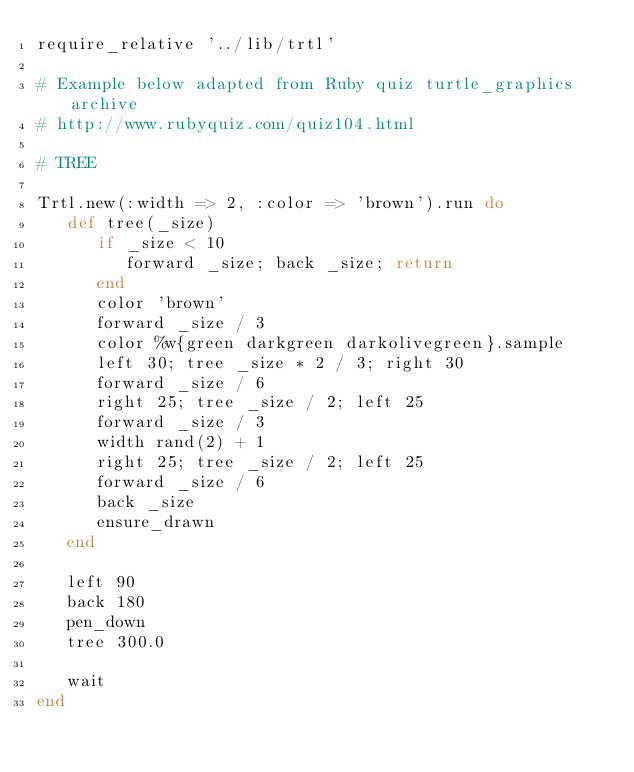<code> <loc_0><loc_0><loc_500><loc_500><_Ruby_>require_relative '../lib/trtl'

# Example below adapted from Ruby quiz turtle_graphics archive
# http://www.rubyquiz.com/quiz104.html

# TREE

Trtl.new(:width => 2, :color => 'brown').run do
   def tree(_size)
      if _size < 10
         forward _size; back _size; return
      end
      color 'brown'
      forward _size / 3
      color %w{green darkgreen darkolivegreen}.sample
      left 30; tree _size * 2 / 3; right 30
      forward _size / 6
      right 25; tree _size / 2; left 25
      forward _size / 3
      width rand(2) + 1
      right 25; tree _size / 2; left 25
      forward _size / 6
      back _size
      ensure_drawn
   end
   
   left 90
   back 180
   pen_down
   tree 300.0

   wait
end
</code> 